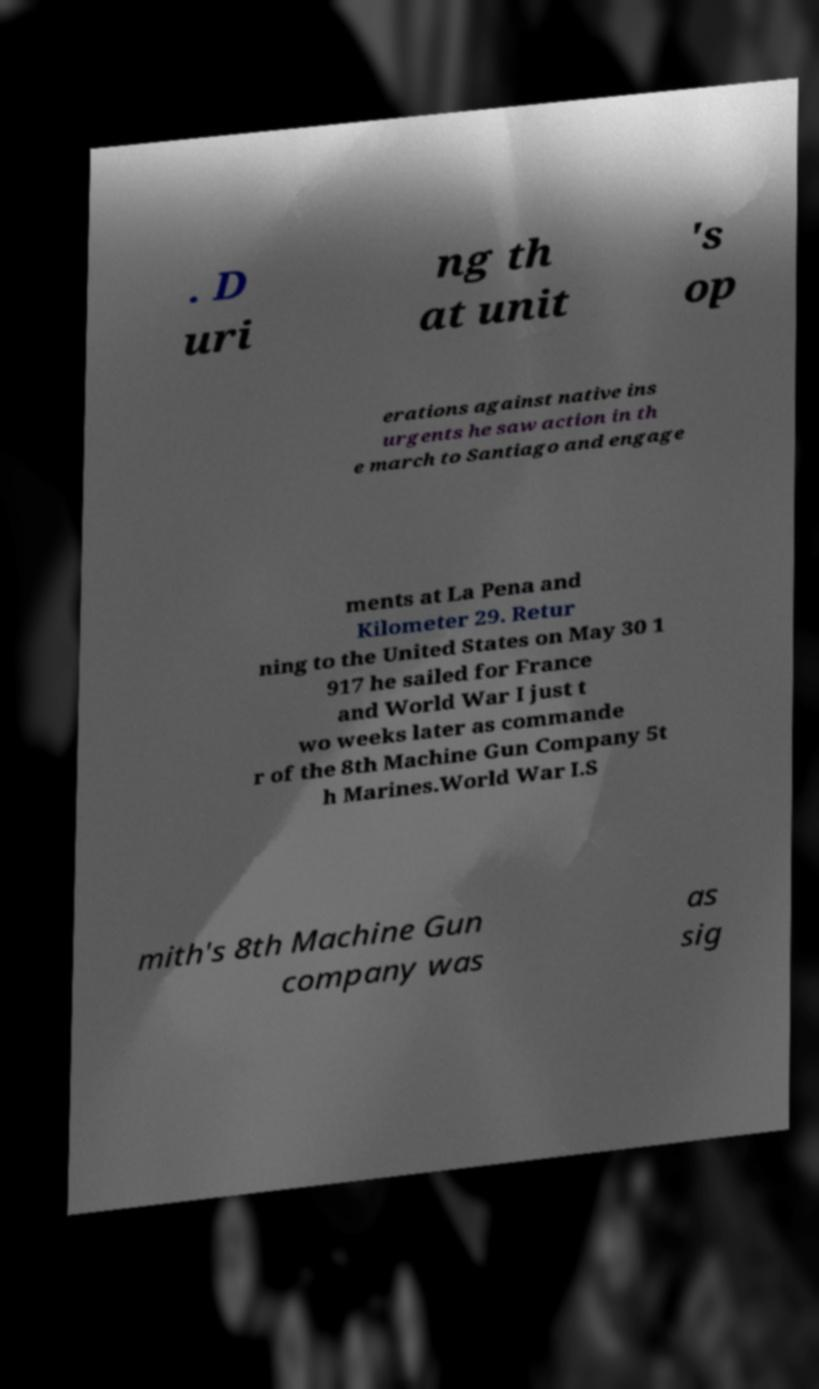For documentation purposes, I need the text within this image transcribed. Could you provide that? . D uri ng th at unit 's op erations against native ins urgents he saw action in th e march to Santiago and engage ments at La Pena and Kilometer 29. Retur ning to the United States on May 30 1 917 he sailed for France and World War I just t wo weeks later as commande r of the 8th Machine Gun Company 5t h Marines.World War I.S mith's 8th Machine Gun company was as sig 